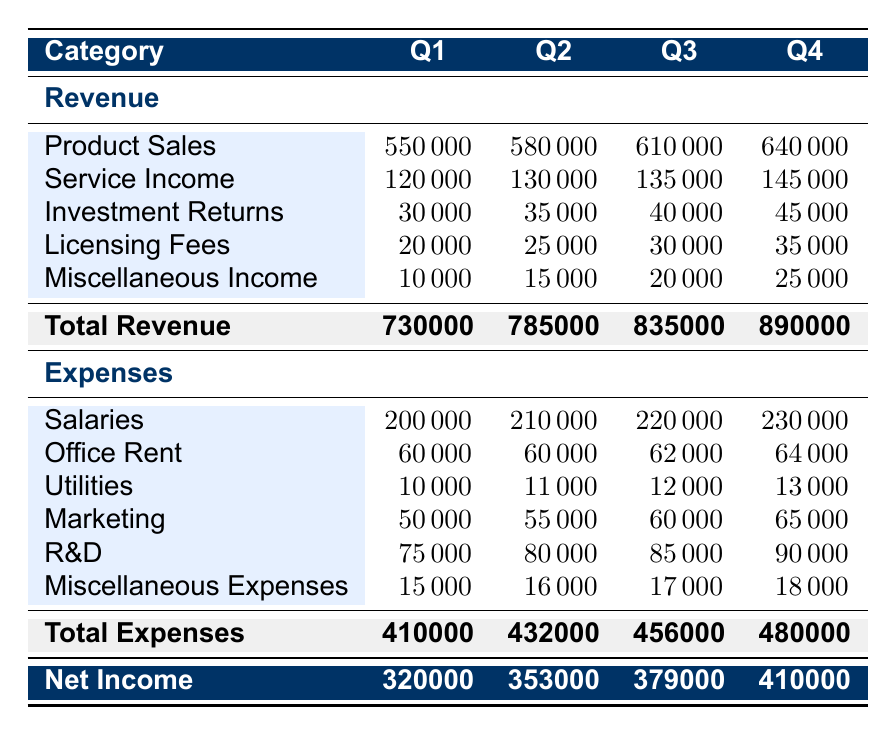What was the total revenue in Q2? The total revenue for Q2 is provided in the table under the "Total Revenue" row and the "Q2" column. It shows a value of 785000.
Answer: 785000 What was the total expense for Q4? The total expense for Q4 is found in the table under the "Total Expenses" row and the "Q4" column. The value shown is 480000.
Answer: 480000 Did the investment returns increase every quarter in 2022? To determine this, we examine the investment returns for each quarter: Q1 is 30000, Q2 is 35000, Q3 is 40000, and Q4 is 45000. Since each subsequent value is greater than the previous, the statement is true.
Answer: Yes What was the average salary expense for the year? We sum the salaries for all four quarters: 200000 + 210000 + 220000 + 230000 = 860000. There are four quarters, so the average is 860000 / 4 = 215000.
Answer: 215000 Which quarter had the highest miscellaneous income? We need to look at the "Miscellaneous Income" values for each quarter: Q1 is 10000, Q2 is 15000, Q3 is 20000, and Q4 is 25000. The highest value is in Q4, which is 25000.
Answer: Q4 What is the total net income for the year? The net income for each quarter is listed in the "Net Income" row at the bottom: Q1 is 320000, Q2 is 353000, Q3 is 379000, and Q4 is 410000. To find the total net income for the year, we sum these values: 320000 + 353000 + 379000 + 410000 = 1462000.
Answer: 1462000 Was there an increase in total revenue from Q1 to Q4? We compare the total revenue for Q1 (730000) to Q4 (890000). Since 890000 is greater than 730000, it confirms that there was indeed an increase.
Answer: Yes What is the difference between total revenue in Q3 and total expenses in Q3? The total revenue in Q3 is 835000 and the total expenses in Q3 is 456000. To find the difference, we calculate 835000 - 456000 = 379000.
Answer: 379000 Which quarter had the highest total expenses? We check the total expenses for each quarter: Q1 is 410000, Q2 is 432000, Q3 is 456000, and Q4 is 480000. Q4 has the highest total expenses value of 480000.
Answer: Q4 